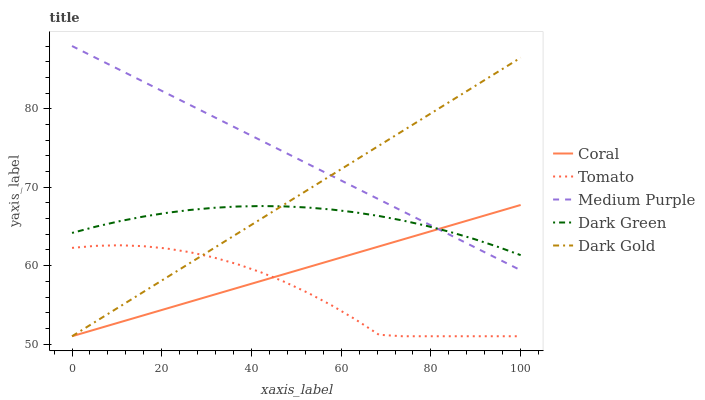Does Tomato have the minimum area under the curve?
Answer yes or no. Yes. Does Medium Purple have the maximum area under the curve?
Answer yes or no. Yes. Does Coral have the minimum area under the curve?
Answer yes or no. No. Does Coral have the maximum area under the curve?
Answer yes or no. No. Is Dark Gold the smoothest?
Answer yes or no. Yes. Is Tomato the roughest?
Answer yes or no. Yes. Is Medium Purple the smoothest?
Answer yes or no. No. Is Medium Purple the roughest?
Answer yes or no. No. Does Tomato have the lowest value?
Answer yes or no. Yes. Does Medium Purple have the lowest value?
Answer yes or no. No. Does Medium Purple have the highest value?
Answer yes or no. Yes. Does Coral have the highest value?
Answer yes or no. No. Is Tomato less than Medium Purple?
Answer yes or no. Yes. Is Medium Purple greater than Tomato?
Answer yes or no. Yes. Does Tomato intersect Coral?
Answer yes or no. Yes. Is Tomato less than Coral?
Answer yes or no. No. Is Tomato greater than Coral?
Answer yes or no. No. Does Tomato intersect Medium Purple?
Answer yes or no. No. 